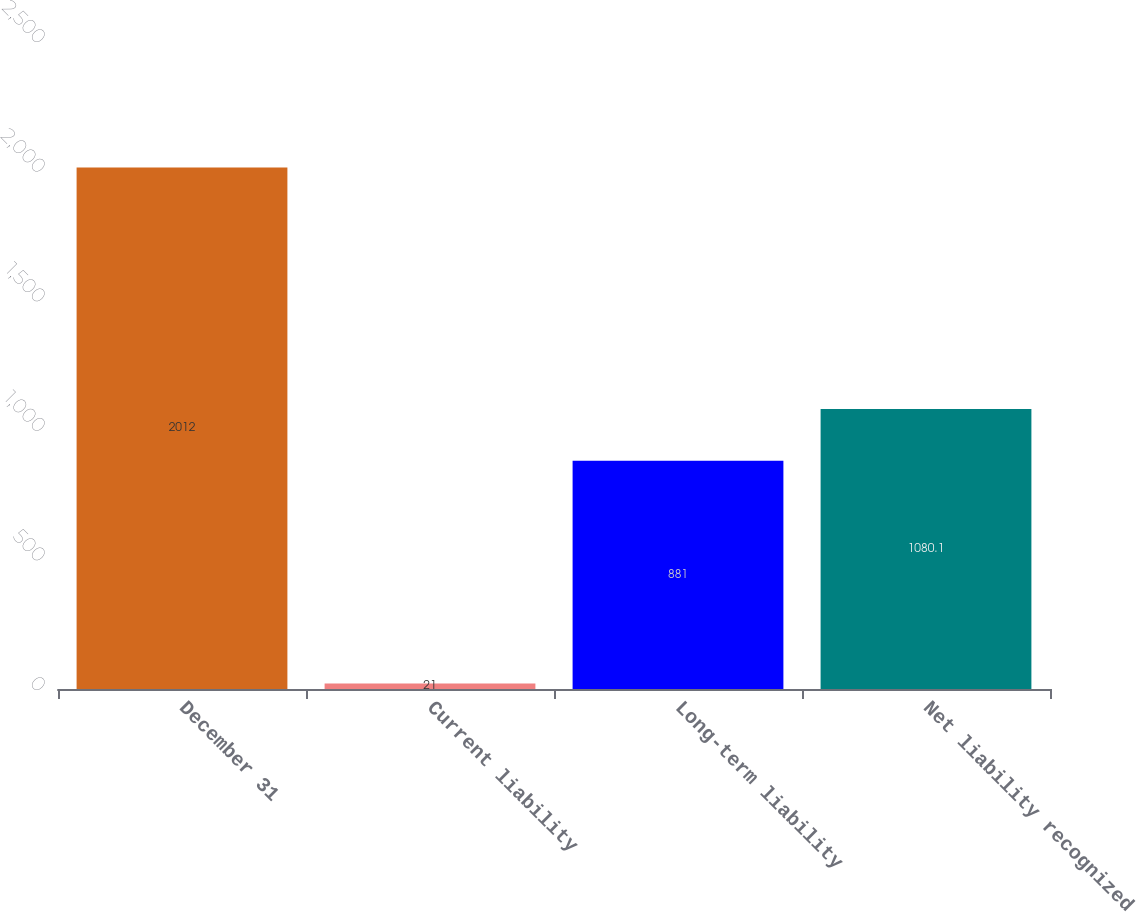<chart> <loc_0><loc_0><loc_500><loc_500><bar_chart><fcel>December 31<fcel>Current liability<fcel>Long-term liability<fcel>Net liability recognized<nl><fcel>2012<fcel>21<fcel>881<fcel>1080.1<nl></chart> 